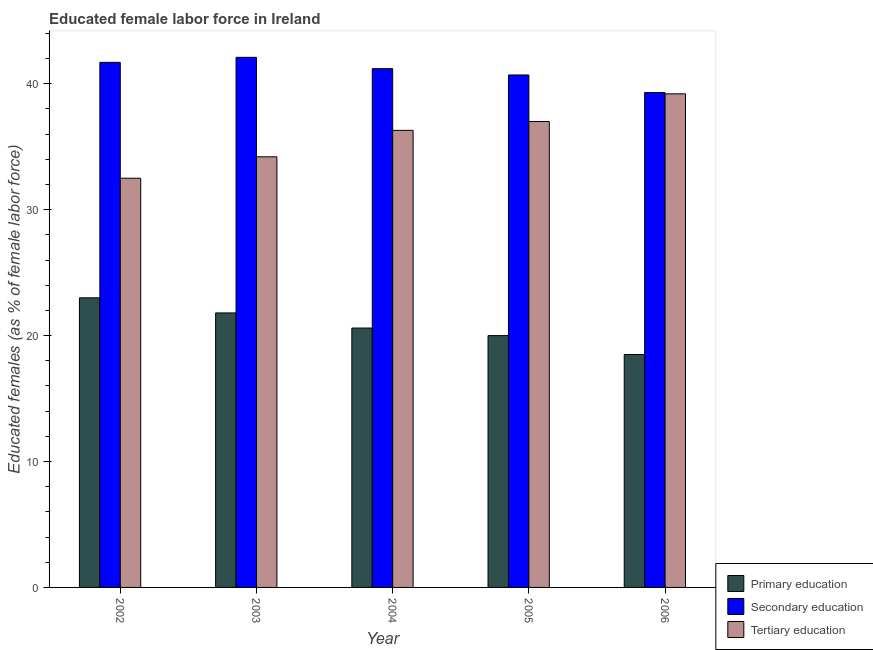How many groups of bars are there?
Your response must be concise. 5. Are the number of bars per tick equal to the number of legend labels?
Your answer should be very brief. Yes. How many bars are there on the 2nd tick from the left?
Keep it short and to the point. 3. What is the label of the 3rd group of bars from the left?
Offer a very short reply. 2004. In how many cases, is the number of bars for a given year not equal to the number of legend labels?
Give a very brief answer. 0. What is the percentage of female labor force who received secondary education in 2002?
Your answer should be very brief. 41.7. Across all years, what is the minimum percentage of female labor force who received secondary education?
Provide a short and direct response. 39.3. In which year was the percentage of female labor force who received primary education minimum?
Keep it short and to the point. 2006. What is the total percentage of female labor force who received primary education in the graph?
Your response must be concise. 103.9. What is the difference between the percentage of female labor force who received secondary education in 2003 and that in 2005?
Keep it short and to the point. 1.4. What is the average percentage of female labor force who received secondary education per year?
Ensure brevity in your answer.  41. What is the ratio of the percentage of female labor force who received secondary education in 2003 to that in 2004?
Make the answer very short. 1.02. Is the difference between the percentage of female labor force who received secondary education in 2003 and 2006 greater than the difference between the percentage of female labor force who received primary education in 2003 and 2006?
Your response must be concise. No. What is the difference between the highest and the second highest percentage of female labor force who received secondary education?
Make the answer very short. 0.4. What is the difference between the highest and the lowest percentage of female labor force who received secondary education?
Provide a short and direct response. 2.8. In how many years, is the percentage of female labor force who received secondary education greater than the average percentage of female labor force who received secondary education taken over all years?
Your answer should be compact. 3. What does the 3rd bar from the right in 2004 represents?
Provide a short and direct response. Primary education. Is it the case that in every year, the sum of the percentage of female labor force who received primary education and percentage of female labor force who received secondary education is greater than the percentage of female labor force who received tertiary education?
Keep it short and to the point. Yes. Are all the bars in the graph horizontal?
Your response must be concise. No. How many years are there in the graph?
Your answer should be compact. 5. What is the difference between two consecutive major ticks on the Y-axis?
Ensure brevity in your answer.  10. Does the graph contain any zero values?
Give a very brief answer. No. Does the graph contain grids?
Your answer should be compact. No. How many legend labels are there?
Provide a short and direct response. 3. How are the legend labels stacked?
Your answer should be very brief. Vertical. What is the title of the graph?
Offer a very short reply. Educated female labor force in Ireland. What is the label or title of the Y-axis?
Offer a very short reply. Educated females (as % of female labor force). What is the Educated females (as % of female labor force) in Secondary education in 2002?
Provide a succinct answer. 41.7. What is the Educated females (as % of female labor force) in Tertiary education in 2002?
Offer a very short reply. 32.5. What is the Educated females (as % of female labor force) in Primary education in 2003?
Make the answer very short. 21.8. What is the Educated females (as % of female labor force) in Secondary education in 2003?
Your answer should be very brief. 42.1. What is the Educated females (as % of female labor force) of Tertiary education in 2003?
Keep it short and to the point. 34.2. What is the Educated females (as % of female labor force) of Primary education in 2004?
Your answer should be compact. 20.6. What is the Educated females (as % of female labor force) in Secondary education in 2004?
Provide a succinct answer. 41.2. What is the Educated females (as % of female labor force) in Tertiary education in 2004?
Your response must be concise. 36.3. What is the Educated females (as % of female labor force) in Secondary education in 2005?
Offer a very short reply. 40.7. What is the Educated females (as % of female labor force) of Tertiary education in 2005?
Provide a succinct answer. 37. What is the Educated females (as % of female labor force) in Secondary education in 2006?
Provide a short and direct response. 39.3. What is the Educated females (as % of female labor force) in Tertiary education in 2006?
Your answer should be compact. 39.2. Across all years, what is the maximum Educated females (as % of female labor force) of Primary education?
Keep it short and to the point. 23. Across all years, what is the maximum Educated females (as % of female labor force) in Secondary education?
Your answer should be very brief. 42.1. Across all years, what is the maximum Educated females (as % of female labor force) in Tertiary education?
Provide a short and direct response. 39.2. Across all years, what is the minimum Educated females (as % of female labor force) of Secondary education?
Offer a very short reply. 39.3. Across all years, what is the minimum Educated females (as % of female labor force) in Tertiary education?
Your answer should be very brief. 32.5. What is the total Educated females (as % of female labor force) in Primary education in the graph?
Give a very brief answer. 103.9. What is the total Educated females (as % of female labor force) in Secondary education in the graph?
Your answer should be very brief. 205. What is the total Educated females (as % of female labor force) in Tertiary education in the graph?
Provide a succinct answer. 179.2. What is the difference between the Educated females (as % of female labor force) in Primary education in 2002 and that in 2003?
Make the answer very short. 1.2. What is the difference between the Educated females (as % of female labor force) in Secondary education in 2002 and that in 2003?
Make the answer very short. -0.4. What is the difference between the Educated females (as % of female labor force) of Tertiary education in 2002 and that in 2003?
Provide a short and direct response. -1.7. What is the difference between the Educated females (as % of female labor force) of Primary education in 2002 and that in 2005?
Offer a very short reply. 3. What is the difference between the Educated females (as % of female labor force) of Tertiary education in 2002 and that in 2005?
Your answer should be very brief. -4.5. What is the difference between the Educated females (as % of female labor force) of Primary education in 2002 and that in 2006?
Your response must be concise. 4.5. What is the difference between the Educated females (as % of female labor force) in Primary education in 2003 and that in 2004?
Give a very brief answer. 1.2. What is the difference between the Educated females (as % of female labor force) of Primary education in 2003 and that in 2005?
Provide a short and direct response. 1.8. What is the difference between the Educated females (as % of female labor force) in Secondary education in 2003 and that in 2005?
Offer a very short reply. 1.4. What is the difference between the Educated females (as % of female labor force) in Secondary education in 2003 and that in 2006?
Your answer should be very brief. 2.8. What is the difference between the Educated females (as % of female labor force) in Tertiary education in 2003 and that in 2006?
Ensure brevity in your answer.  -5. What is the difference between the Educated females (as % of female labor force) in Primary education in 2004 and that in 2005?
Give a very brief answer. 0.6. What is the difference between the Educated females (as % of female labor force) in Primary education in 2004 and that in 2006?
Offer a terse response. 2.1. What is the difference between the Educated females (as % of female labor force) in Secondary education in 2004 and that in 2006?
Your answer should be compact. 1.9. What is the difference between the Educated females (as % of female labor force) of Secondary education in 2005 and that in 2006?
Your response must be concise. 1.4. What is the difference between the Educated females (as % of female labor force) of Primary education in 2002 and the Educated females (as % of female labor force) of Secondary education in 2003?
Your response must be concise. -19.1. What is the difference between the Educated females (as % of female labor force) in Primary education in 2002 and the Educated females (as % of female labor force) in Tertiary education in 2003?
Provide a succinct answer. -11.2. What is the difference between the Educated females (as % of female labor force) of Secondary education in 2002 and the Educated females (as % of female labor force) of Tertiary education in 2003?
Ensure brevity in your answer.  7.5. What is the difference between the Educated females (as % of female labor force) of Primary education in 2002 and the Educated females (as % of female labor force) of Secondary education in 2004?
Offer a terse response. -18.2. What is the difference between the Educated females (as % of female labor force) of Primary education in 2002 and the Educated females (as % of female labor force) of Secondary education in 2005?
Provide a succinct answer. -17.7. What is the difference between the Educated females (as % of female labor force) of Secondary education in 2002 and the Educated females (as % of female labor force) of Tertiary education in 2005?
Offer a very short reply. 4.7. What is the difference between the Educated females (as % of female labor force) of Primary education in 2002 and the Educated females (as % of female labor force) of Secondary education in 2006?
Provide a short and direct response. -16.3. What is the difference between the Educated females (as % of female labor force) of Primary education in 2002 and the Educated females (as % of female labor force) of Tertiary education in 2006?
Make the answer very short. -16.2. What is the difference between the Educated females (as % of female labor force) in Secondary education in 2002 and the Educated females (as % of female labor force) in Tertiary education in 2006?
Make the answer very short. 2.5. What is the difference between the Educated females (as % of female labor force) in Primary education in 2003 and the Educated females (as % of female labor force) in Secondary education in 2004?
Offer a terse response. -19.4. What is the difference between the Educated females (as % of female labor force) in Primary education in 2003 and the Educated females (as % of female labor force) in Secondary education in 2005?
Provide a succinct answer. -18.9. What is the difference between the Educated females (as % of female labor force) of Primary education in 2003 and the Educated females (as % of female labor force) of Tertiary education in 2005?
Offer a very short reply. -15.2. What is the difference between the Educated females (as % of female labor force) of Primary education in 2003 and the Educated females (as % of female labor force) of Secondary education in 2006?
Keep it short and to the point. -17.5. What is the difference between the Educated females (as % of female labor force) in Primary education in 2003 and the Educated females (as % of female labor force) in Tertiary education in 2006?
Provide a short and direct response. -17.4. What is the difference between the Educated females (as % of female labor force) of Secondary education in 2003 and the Educated females (as % of female labor force) of Tertiary education in 2006?
Provide a succinct answer. 2.9. What is the difference between the Educated females (as % of female labor force) of Primary education in 2004 and the Educated females (as % of female labor force) of Secondary education in 2005?
Make the answer very short. -20.1. What is the difference between the Educated females (as % of female labor force) of Primary education in 2004 and the Educated females (as % of female labor force) of Tertiary education in 2005?
Offer a very short reply. -16.4. What is the difference between the Educated females (as % of female labor force) in Secondary education in 2004 and the Educated females (as % of female labor force) in Tertiary education in 2005?
Your answer should be very brief. 4.2. What is the difference between the Educated females (as % of female labor force) in Primary education in 2004 and the Educated females (as % of female labor force) in Secondary education in 2006?
Your response must be concise. -18.7. What is the difference between the Educated females (as % of female labor force) in Primary education in 2004 and the Educated females (as % of female labor force) in Tertiary education in 2006?
Your answer should be compact. -18.6. What is the difference between the Educated females (as % of female labor force) of Secondary education in 2004 and the Educated females (as % of female labor force) of Tertiary education in 2006?
Provide a succinct answer. 2. What is the difference between the Educated females (as % of female labor force) in Primary education in 2005 and the Educated females (as % of female labor force) in Secondary education in 2006?
Give a very brief answer. -19.3. What is the difference between the Educated females (as % of female labor force) in Primary education in 2005 and the Educated females (as % of female labor force) in Tertiary education in 2006?
Offer a terse response. -19.2. What is the difference between the Educated females (as % of female labor force) of Secondary education in 2005 and the Educated females (as % of female labor force) of Tertiary education in 2006?
Keep it short and to the point. 1.5. What is the average Educated females (as % of female labor force) of Primary education per year?
Provide a short and direct response. 20.78. What is the average Educated females (as % of female labor force) of Secondary education per year?
Keep it short and to the point. 41. What is the average Educated females (as % of female labor force) of Tertiary education per year?
Provide a succinct answer. 35.84. In the year 2002, what is the difference between the Educated females (as % of female labor force) in Primary education and Educated females (as % of female labor force) in Secondary education?
Provide a succinct answer. -18.7. In the year 2002, what is the difference between the Educated females (as % of female labor force) of Primary education and Educated females (as % of female labor force) of Tertiary education?
Your answer should be very brief. -9.5. In the year 2003, what is the difference between the Educated females (as % of female labor force) in Primary education and Educated females (as % of female labor force) in Secondary education?
Give a very brief answer. -20.3. In the year 2003, what is the difference between the Educated females (as % of female labor force) in Primary education and Educated females (as % of female labor force) in Tertiary education?
Offer a terse response. -12.4. In the year 2004, what is the difference between the Educated females (as % of female labor force) of Primary education and Educated females (as % of female labor force) of Secondary education?
Offer a very short reply. -20.6. In the year 2004, what is the difference between the Educated females (as % of female labor force) of Primary education and Educated females (as % of female labor force) of Tertiary education?
Provide a succinct answer. -15.7. In the year 2004, what is the difference between the Educated females (as % of female labor force) in Secondary education and Educated females (as % of female labor force) in Tertiary education?
Make the answer very short. 4.9. In the year 2005, what is the difference between the Educated females (as % of female labor force) of Primary education and Educated females (as % of female labor force) of Secondary education?
Your answer should be very brief. -20.7. In the year 2005, what is the difference between the Educated females (as % of female labor force) of Primary education and Educated females (as % of female labor force) of Tertiary education?
Your response must be concise. -17. In the year 2005, what is the difference between the Educated females (as % of female labor force) in Secondary education and Educated females (as % of female labor force) in Tertiary education?
Provide a short and direct response. 3.7. In the year 2006, what is the difference between the Educated females (as % of female labor force) of Primary education and Educated females (as % of female labor force) of Secondary education?
Ensure brevity in your answer.  -20.8. In the year 2006, what is the difference between the Educated females (as % of female labor force) of Primary education and Educated females (as % of female labor force) of Tertiary education?
Keep it short and to the point. -20.7. In the year 2006, what is the difference between the Educated females (as % of female labor force) in Secondary education and Educated females (as % of female labor force) in Tertiary education?
Your response must be concise. 0.1. What is the ratio of the Educated females (as % of female labor force) of Primary education in 2002 to that in 2003?
Provide a short and direct response. 1.05. What is the ratio of the Educated females (as % of female labor force) of Tertiary education in 2002 to that in 2003?
Ensure brevity in your answer.  0.95. What is the ratio of the Educated females (as % of female labor force) of Primary education in 2002 to that in 2004?
Provide a succinct answer. 1.12. What is the ratio of the Educated females (as % of female labor force) in Secondary education in 2002 to that in 2004?
Provide a short and direct response. 1.01. What is the ratio of the Educated females (as % of female labor force) in Tertiary education in 2002 to that in 2004?
Make the answer very short. 0.9. What is the ratio of the Educated females (as % of female labor force) in Primary education in 2002 to that in 2005?
Give a very brief answer. 1.15. What is the ratio of the Educated females (as % of female labor force) in Secondary education in 2002 to that in 2005?
Your answer should be compact. 1.02. What is the ratio of the Educated females (as % of female labor force) in Tertiary education in 2002 to that in 2005?
Your response must be concise. 0.88. What is the ratio of the Educated females (as % of female labor force) of Primary education in 2002 to that in 2006?
Offer a terse response. 1.24. What is the ratio of the Educated females (as % of female labor force) of Secondary education in 2002 to that in 2006?
Your response must be concise. 1.06. What is the ratio of the Educated females (as % of female labor force) in Tertiary education in 2002 to that in 2006?
Offer a very short reply. 0.83. What is the ratio of the Educated females (as % of female labor force) of Primary education in 2003 to that in 2004?
Your answer should be compact. 1.06. What is the ratio of the Educated females (as % of female labor force) in Secondary education in 2003 to that in 2004?
Ensure brevity in your answer.  1.02. What is the ratio of the Educated females (as % of female labor force) in Tertiary education in 2003 to that in 2004?
Provide a short and direct response. 0.94. What is the ratio of the Educated females (as % of female labor force) of Primary education in 2003 to that in 2005?
Your answer should be compact. 1.09. What is the ratio of the Educated females (as % of female labor force) of Secondary education in 2003 to that in 2005?
Make the answer very short. 1.03. What is the ratio of the Educated females (as % of female labor force) in Tertiary education in 2003 to that in 2005?
Your answer should be compact. 0.92. What is the ratio of the Educated females (as % of female labor force) in Primary education in 2003 to that in 2006?
Your answer should be very brief. 1.18. What is the ratio of the Educated females (as % of female labor force) in Secondary education in 2003 to that in 2006?
Ensure brevity in your answer.  1.07. What is the ratio of the Educated females (as % of female labor force) of Tertiary education in 2003 to that in 2006?
Keep it short and to the point. 0.87. What is the ratio of the Educated females (as % of female labor force) in Primary education in 2004 to that in 2005?
Your answer should be very brief. 1.03. What is the ratio of the Educated females (as % of female labor force) of Secondary education in 2004 to that in 2005?
Provide a succinct answer. 1.01. What is the ratio of the Educated females (as % of female labor force) of Tertiary education in 2004 to that in 2005?
Ensure brevity in your answer.  0.98. What is the ratio of the Educated females (as % of female labor force) of Primary education in 2004 to that in 2006?
Offer a terse response. 1.11. What is the ratio of the Educated females (as % of female labor force) in Secondary education in 2004 to that in 2006?
Ensure brevity in your answer.  1.05. What is the ratio of the Educated females (as % of female labor force) in Tertiary education in 2004 to that in 2006?
Provide a succinct answer. 0.93. What is the ratio of the Educated females (as % of female labor force) of Primary education in 2005 to that in 2006?
Ensure brevity in your answer.  1.08. What is the ratio of the Educated females (as % of female labor force) of Secondary education in 2005 to that in 2006?
Ensure brevity in your answer.  1.04. What is the ratio of the Educated females (as % of female labor force) of Tertiary education in 2005 to that in 2006?
Offer a terse response. 0.94. What is the difference between the highest and the second highest Educated females (as % of female labor force) in Primary education?
Offer a very short reply. 1.2. What is the difference between the highest and the second highest Educated females (as % of female labor force) of Secondary education?
Your answer should be very brief. 0.4. What is the difference between the highest and the second highest Educated females (as % of female labor force) of Tertiary education?
Ensure brevity in your answer.  2.2. 